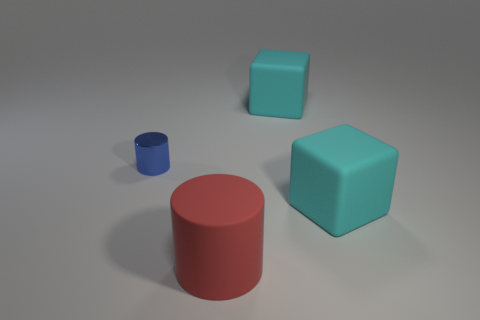What is the material of the big object that is both behind the large red rubber thing and in front of the metallic object?
Offer a terse response. Rubber. Do the large red object and the small object have the same material?
Keep it short and to the point. No. What number of cubes are the same size as the red cylinder?
Ensure brevity in your answer.  2. Are there an equal number of things that are in front of the small blue cylinder and big cyan things?
Offer a very short reply. Yes. How many objects are both to the left of the big cylinder and behind the tiny blue cylinder?
Provide a short and direct response. 0. Is the shape of the large cyan object behind the tiny cylinder the same as  the tiny blue metal object?
Offer a very short reply. No. Are there an equal number of cyan rubber cubes that are right of the small blue cylinder and cyan matte things right of the rubber cylinder?
Keep it short and to the point. Yes. There is a cyan matte object in front of the large rubber object behind the shiny thing; what number of large blocks are behind it?
Provide a short and direct response. 1. Does the tiny shiny cylinder have the same color as the large matte cube that is in front of the tiny blue cylinder?
Your answer should be very brief. No. Is the number of blue shiny objects behind the tiny blue thing greater than the number of shiny things?
Provide a short and direct response. No. 